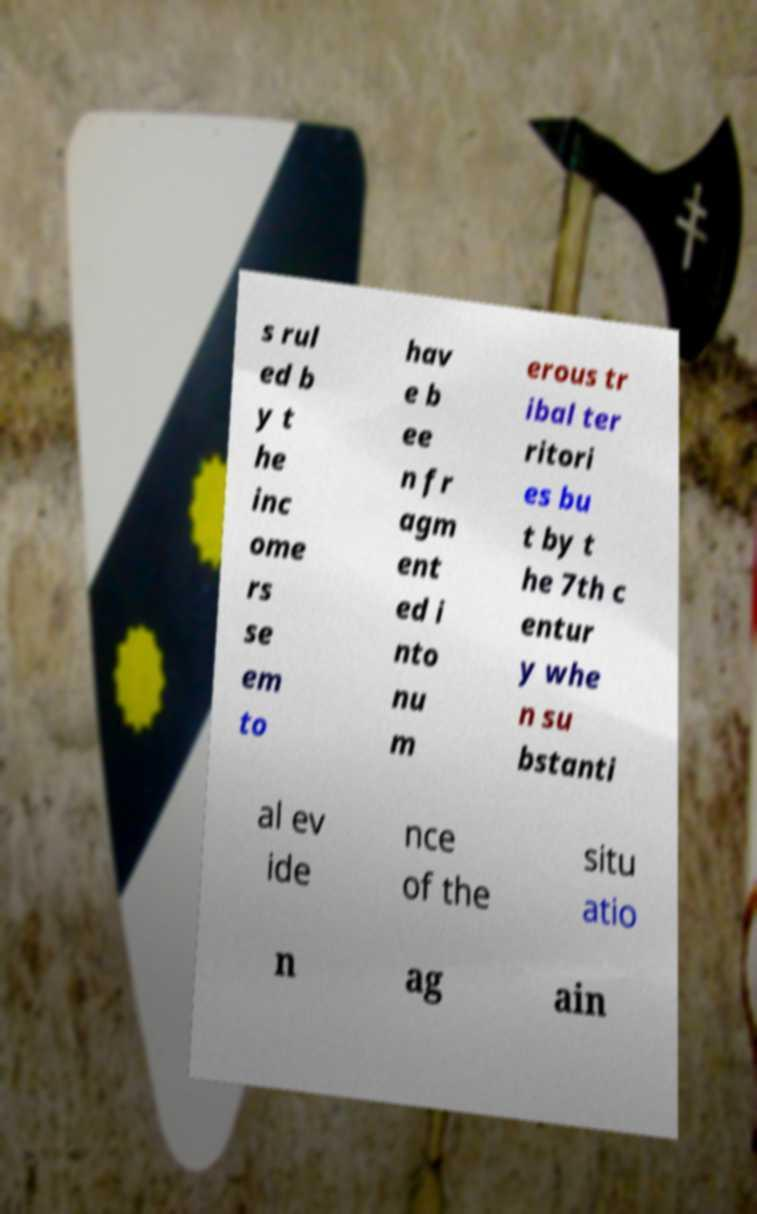Please identify and transcribe the text found in this image. s rul ed b y t he inc ome rs se em to hav e b ee n fr agm ent ed i nto nu m erous tr ibal ter ritori es bu t by t he 7th c entur y whe n su bstanti al ev ide nce of the situ atio n ag ain 